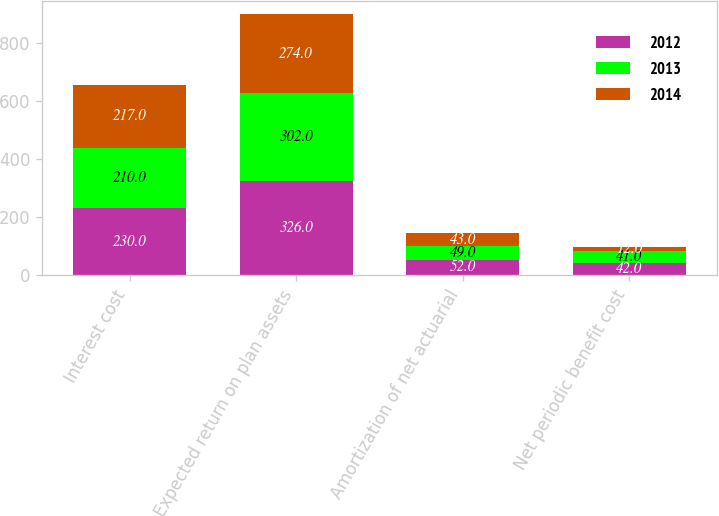Convert chart. <chart><loc_0><loc_0><loc_500><loc_500><stacked_bar_chart><ecel><fcel>Interest cost<fcel>Expected return on plan assets<fcel>Amortization of net actuarial<fcel>Net periodic benefit cost<nl><fcel>2012<fcel>230<fcel>326<fcel>52<fcel>42<nl><fcel>2013<fcel>210<fcel>302<fcel>49<fcel>41<nl><fcel>2014<fcel>217<fcel>274<fcel>43<fcel>12<nl></chart> 